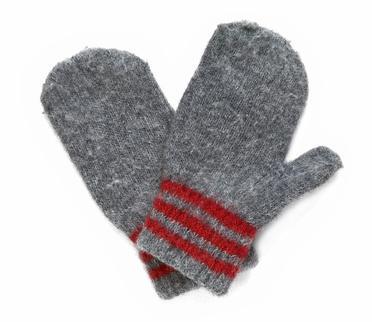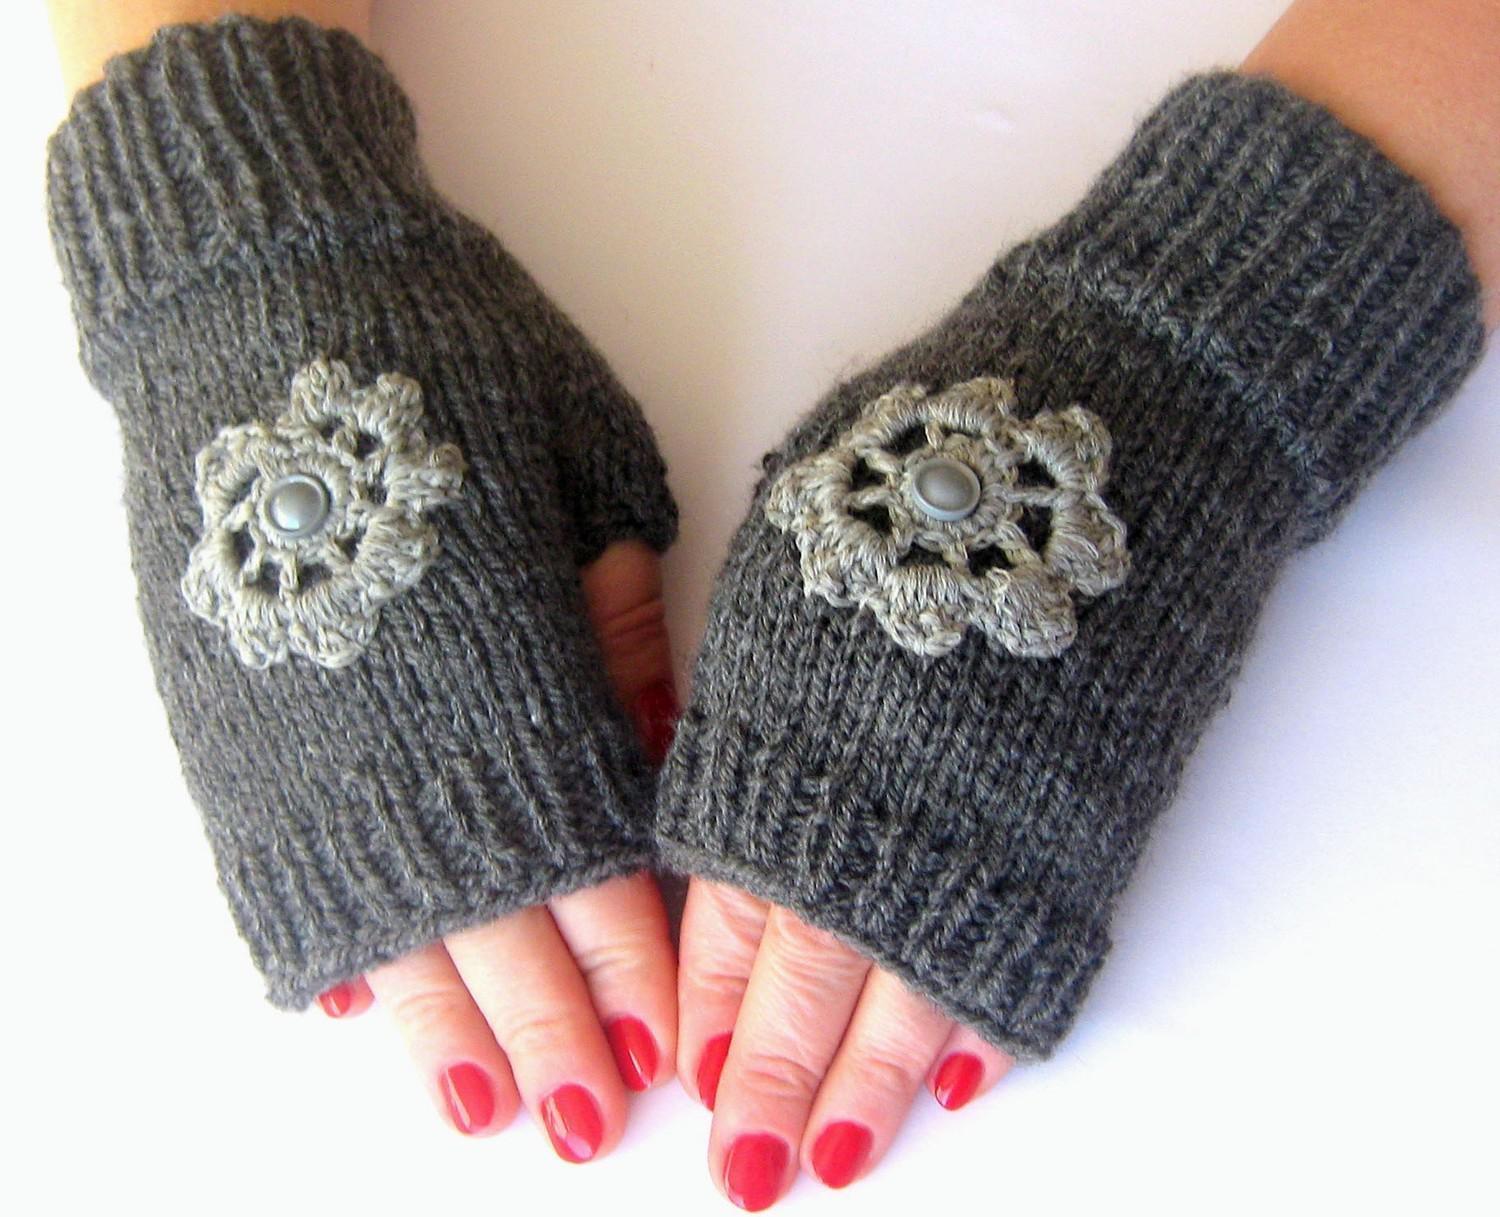The first image is the image on the left, the second image is the image on the right. For the images displayed, is the sentence "The mittens in the image on the left are made of a solid color." factually correct? Answer yes or no. No. The first image is the image on the left, the second image is the image on the right. Evaluate the accuracy of this statement regarding the images: "Two pairs of traditional mittens are shown, with the fingers covered by one rounded section.". Is it true? Answer yes or no. No. 